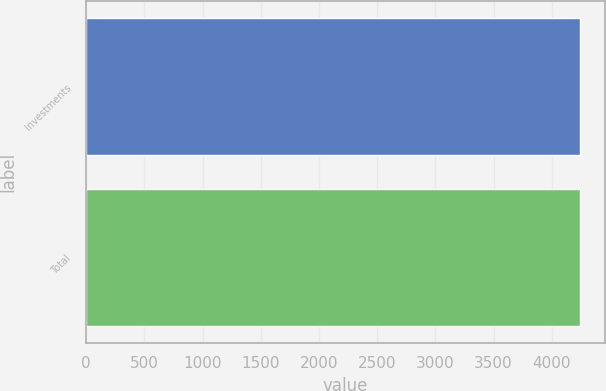Convert chart to OTSL. <chart><loc_0><loc_0><loc_500><loc_500><bar_chart><fcel>Investments<fcel>Total<nl><fcel>4242<fcel>4242.1<nl></chart> 